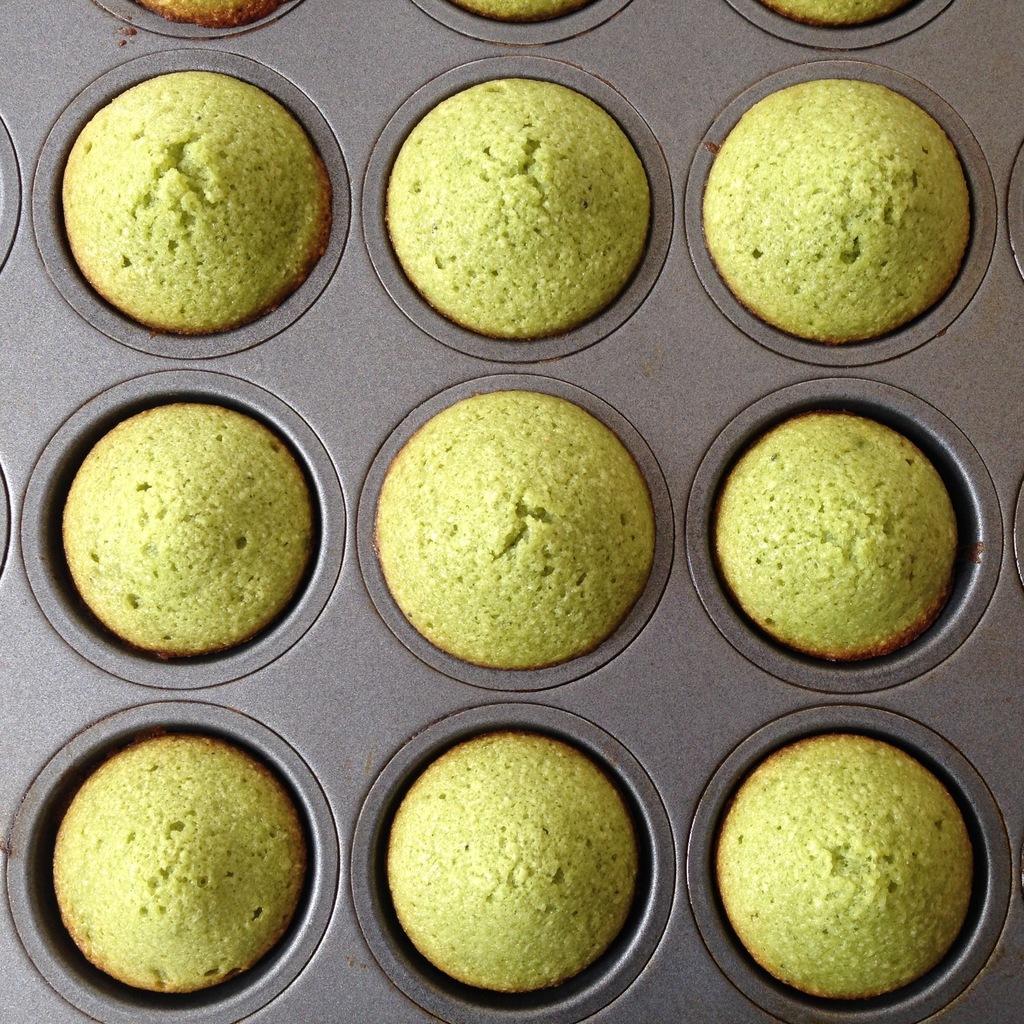In one or two sentences, can you explain what this image depicts? In the image there are cookies in a tray. 